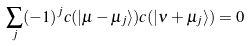<formula> <loc_0><loc_0><loc_500><loc_500>\sum _ { j } ( - 1 ) ^ { j } c ( | \mu - \mu _ { j } \rangle ) c ( | \nu + \mu _ { j } \rangle ) = 0</formula> 